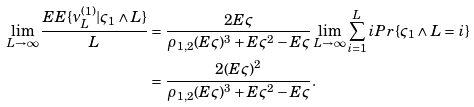<formula> <loc_0><loc_0><loc_500><loc_500>\lim _ { L \to \infty } \frac { E E \{ \nu _ { L } ^ { ( 1 ) } | \varsigma _ { 1 } \wedge L \} } { L } & = \frac { 2 E \varsigma } { \rho _ { 1 , 2 } ( E \varsigma ) ^ { 3 } + E \varsigma ^ { 2 } - E \varsigma } \lim _ { L \to \infty } \sum _ { i = 1 } ^ { L } i P r \{ \varsigma _ { 1 } \wedge L = i \} \\ & = \frac { 2 ( E \varsigma ) ^ { 2 } } { \rho _ { 1 , 2 } ( E \varsigma ) ^ { 3 } + E \varsigma ^ { 2 } - E \varsigma } .</formula> 